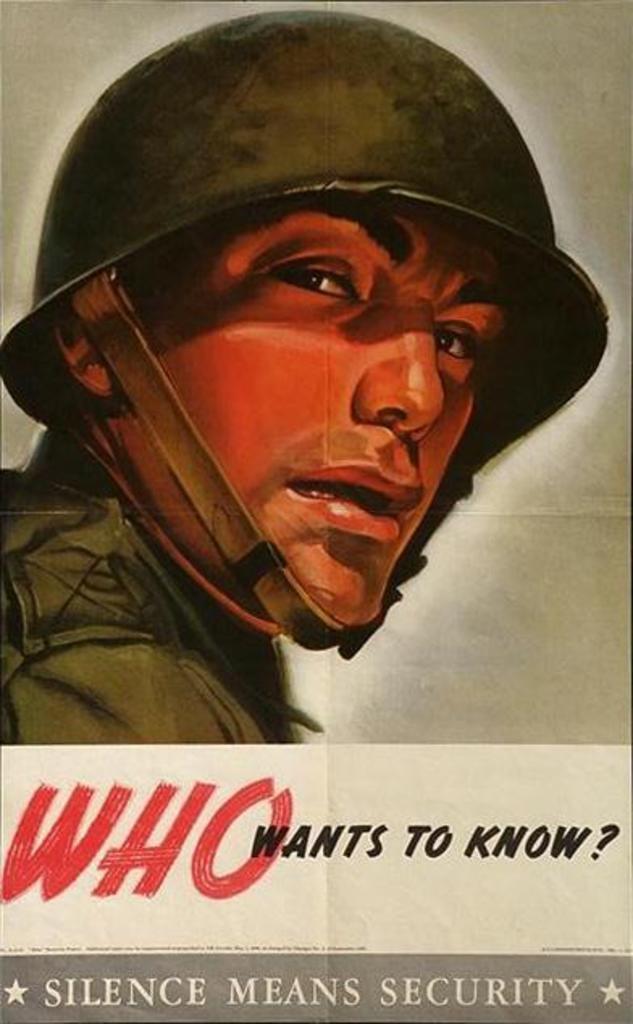What does silence mean?
Your response must be concise. Security. What word is in big red letters?
Your response must be concise. Who. 